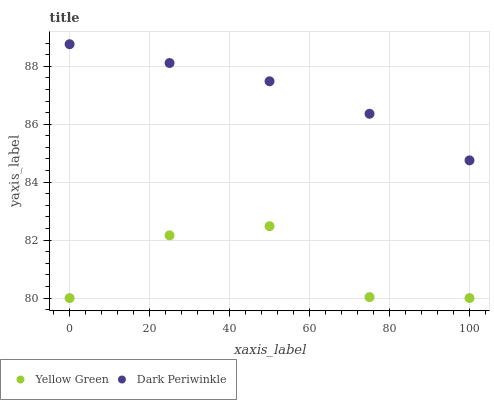Does Yellow Green have the minimum area under the curve?
Answer yes or no. Yes. Does Dark Periwinkle have the maximum area under the curve?
Answer yes or no. Yes. Does Dark Periwinkle have the minimum area under the curve?
Answer yes or no. No. Is Dark Periwinkle the smoothest?
Answer yes or no. Yes. Is Yellow Green the roughest?
Answer yes or no. Yes. Is Dark Periwinkle the roughest?
Answer yes or no. No. Does Yellow Green have the lowest value?
Answer yes or no. Yes. Does Dark Periwinkle have the lowest value?
Answer yes or no. No. Does Dark Periwinkle have the highest value?
Answer yes or no. Yes. Is Yellow Green less than Dark Periwinkle?
Answer yes or no. Yes. Is Dark Periwinkle greater than Yellow Green?
Answer yes or no. Yes. Does Yellow Green intersect Dark Periwinkle?
Answer yes or no. No. 